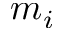<formula> <loc_0><loc_0><loc_500><loc_500>m _ { i }</formula> 